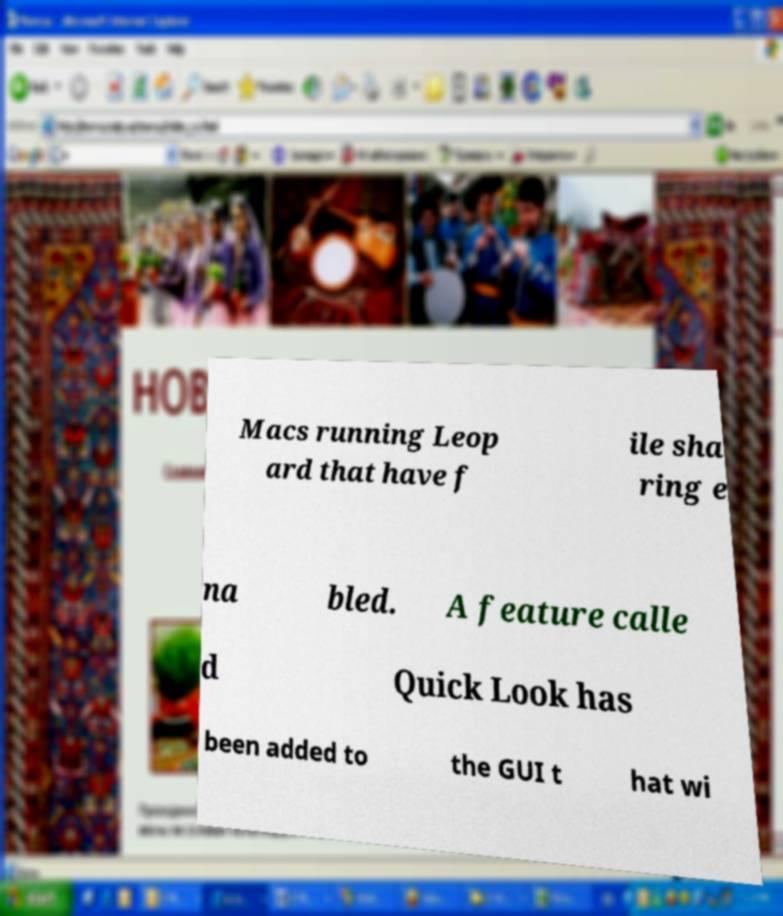What messages or text are displayed in this image? I need them in a readable, typed format. Macs running Leop ard that have f ile sha ring e na bled. A feature calle d Quick Look has been added to the GUI t hat wi 